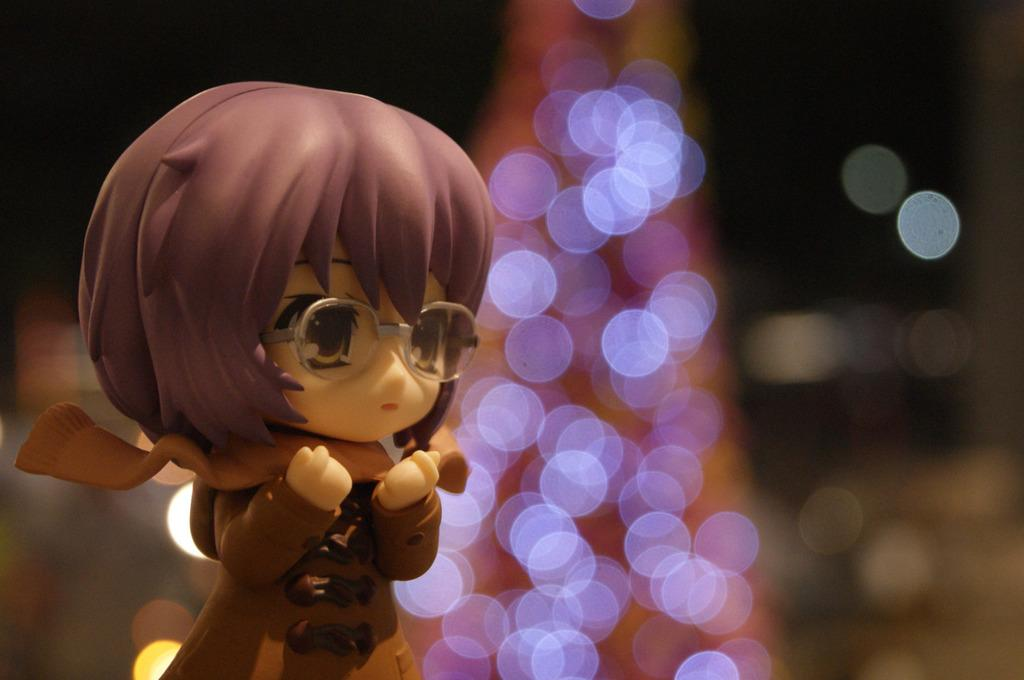What is located on the left side of the image? There is a doll on the left side of the image. Can you describe the background of the image? The background of the image is blurred. What type of wheel is visible on the table in the image? There is no wheel or table present in the image; it only features a doll on the left side and a blurred background. 